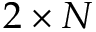Convert formula to latex. <formula><loc_0><loc_0><loc_500><loc_500>2 \times N</formula> 